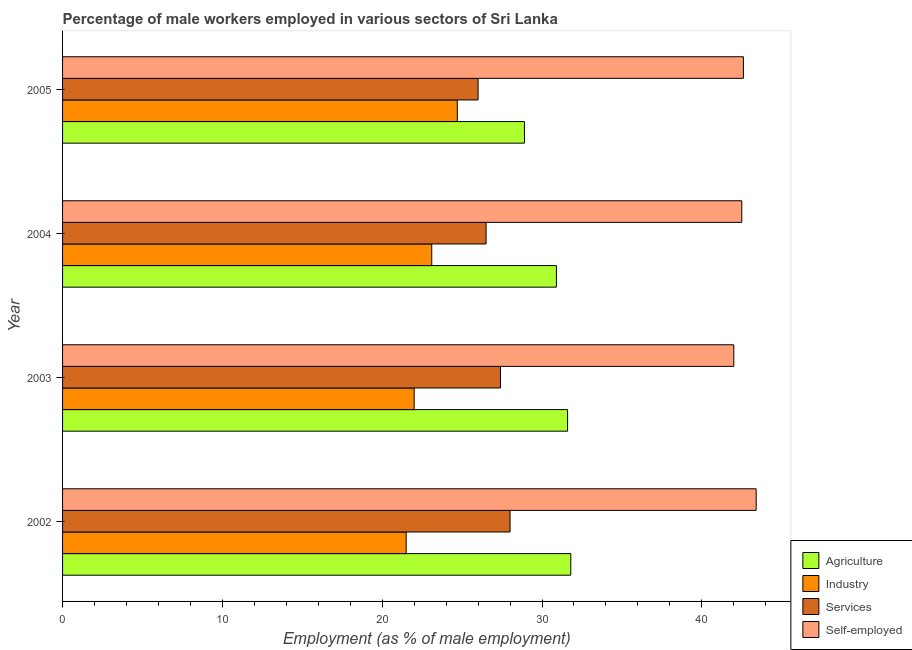In how many cases, is the number of bars for a given year not equal to the number of legend labels?
Offer a very short reply. 0. What is the percentage of male workers in agriculture in 2004?
Your answer should be very brief. 30.9. Across all years, what is the maximum percentage of male workers in industry?
Provide a short and direct response. 24.7. Across all years, what is the minimum percentage of male workers in industry?
Make the answer very short. 21.5. In which year was the percentage of male workers in agriculture maximum?
Provide a succinct answer. 2002. In which year was the percentage of male workers in industry minimum?
Give a very brief answer. 2002. What is the total percentage of male workers in services in the graph?
Ensure brevity in your answer.  107.9. What is the difference between the percentage of male workers in industry in 2005 and the percentage of male workers in agriculture in 2004?
Offer a very short reply. -6.2. What is the average percentage of male workers in agriculture per year?
Give a very brief answer. 30.8. In the year 2004, what is the difference between the percentage of male workers in agriculture and percentage of self employed male workers?
Give a very brief answer. -11.6. What is the ratio of the percentage of male workers in industry in 2002 to that in 2004?
Your answer should be very brief. 0.93. Is the percentage of male workers in agriculture in 2004 less than that in 2005?
Offer a very short reply. No. In how many years, is the percentage of self employed male workers greater than the average percentage of self employed male workers taken over all years?
Make the answer very short. 1. What does the 4th bar from the top in 2005 represents?
Offer a very short reply. Agriculture. What does the 4th bar from the bottom in 2005 represents?
Provide a short and direct response. Self-employed. How many bars are there?
Keep it short and to the point. 16. Are all the bars in the graph horizontal?
Give a very brief answer. Yes. Does the graph contain any zero values?
Ensure brevity in your answer.  No. Where does the legend appear in the graph?
Ensure brevity in your answer.  Bottom right. How many legend labels are there?
Your response must be concise. 4. How are the legend labels stacked?
Ensure brevity in your answer.  Vertical. What is the title of the graph?
Offer a terse response. Percentage of male workers employed in various sectors of Sri Lanka. Does "Public sector management" appear as one of the legend labels in the graph?
Offer a terse response. No. What is the label or title of the X-axis?
Your answer should be compact. Employment (as % of male employment). What is the label or title of the Y-axis?
Your answer should be very brief. Year. What is the Employment (as % of male employment) of Agriculture in 2002?
Your answer should be very brief. 31.8. What is the Employment (as % of male employment) in Industry in 2002?
Provide a succinct answer. 21.5. What is the Employment (as % of male employment) in Self-employed in 2002?
Ensure brevity in your answer.  43.4. What is the Employment (as % of male employment) in Agriculture in 2003?
Offer a very short reply. 31.6. What is the Employment (as % of male employment) of Services in 2003?
Offer a very short reply. 27.4. What is the Employment (as % of male employment) of Agriculture in 2004?
Ensure brevity in your answer.  30.9. What is the Employment (as % of male employment) in Industry in 2004?
Keep it short and to the point. 23.1. What is the Employment (as % of male employment) of Self-employed in 2004?
Your answer should be compact. 42.5. What is the Employment (as % of male employment) in Agriculture in 2005?
Your answer should be compact. 28.9. What is the Employment (as % of male employment) of Industry in 2005?
Your response must be concise. 24.7. What is the Employment (as % of male employment) of Services in 2005?
Provide a short and direct response. 26. What is the Employment (as % of male employment) of Self-employed in 2005?
Your answer should be compact. 42.6. Across all years, what is the maximum Employment (as % of male employment) of Agriculture?
Your response must be concise. 31.8. Across all years, what is the maximum Employment (as % of male employment) in Industry?
Make the answer very short. 24.7. Across all years, what is the maximum Employment (as % of male employment) in Self-employed?
Make the answer very short. 43.4. Across all years, what is the minimum Employment (as % of male employment) of Agriculture?
Make the answer very short. 28.9. What is the total Employment (as % of male employment) of Agriculture in the graph?
Offer a terse response. 123.2. What is the total Employment (as % of male employment) in Industry in the graph?
Offer a terse response. 91.3. What is the total Employment (as % of male employment) in Services in the graph?
Provide a short and direct response. 107.9. What is the total Employment (as % of male employment) in Self-employed in the graph?
Give a very brief answer. 170.5. What is the difference between the Employment (as % of male employment) in Agriculture in 2002 and that in 2003?
Give a very brief answer. 0.2. What is the difference between the Employment (as % of male employment) in Self-employed in 2002 and that in 2003?
Your answer should be very brief. 1.4. What is the difference between the Employment (as % of male employment) in Agriculture in 2002 and that in 2004?
Keep it short and to the point. 0.9. What is the difference between the Employment (as % of male employment) in Industry in 2002 and that in 2004?
Offer a terse response. -1.6. What is the difference between the Employment (as % of male employment) of Self-employed in 2002 and that in 2004?
Your response must be concise. 0.9. What is the difference between the Employment (as % of male employment) of Agriculture in 2002 and that in 2005?
Your answer should be very brief. 2.9. What is the difference between the Employment (as % of male employment) of Industry in 2002 and that in 2005?
Make the answer very short. -3.2. What is the difference between the Employment (as % of male employment) in Services in 2002 and that in 2005?
Offer a very short reply. 2. What is the difference between the Employment (as % of male employment) in Self-employed in 2002 and that in 2005?
Offer a very short reply. 0.8. What is the difference between the Employment (as % of male employment) of Services in 2003 and that in 2004?
Ensure brevity in your answer.  0.9. What is the difference between the Employment (as % of male employment) in Agriculture in 2003 and that in 2005?
Make the answer very short. 2.7. What is the difference between the Employment (as % of male employment) of Services in 2003 and that in 2005?
Provide a succinct answer. 1.4. What is the difference between the Employment (as % of male employment) of Self-employed in 2003 and that in 2005?
Your response must be concise. -0.6. What is the difference between the Employment (as % of male employment) in Agriculture in 2004 and that in 2005?
Provide a succinct answer. 2. What is the difference between the Employment (as % of male employment) of Industry in 2004 and that in 2005?
Ensure brevity in your answer.  -1.6. What is the difference between the Employment (as % of male employment) of Services in 2004 and that in 2005?
Ensure brevity in your answer.  0.5. What is the difference between the Employment (as % of male employment) of Agriculture in 2002 and the Employment (as % of male employment) of Industry in 2003?
Give a very brief answer. 9.8. What is the difference between the Employment (as % of male employment) of Industry in 2002 and the Employment (as % of male employment) of Self-employed in 2003?
Give a very brief answer. -20.5. What is the difference between the Employment (as % of male employment) of Agriculture in 2002 and the Employment (as % of male employment) of Industry in 2004?
Keep it short and to the point. 8.7. What is the difference between the Employment (as % of male employment) of Industry in 2002 and the Employment (as % of male employment) of Services in 2004?
Your answer should be compact. -5. What is the difference between the Employment (as % of male employment) of Industry in 2002 and the Employment (as % of male employment) of Self-employed in 2004?
Offer a terse response. -21. What is the difference between the Employment (as % of male employment) of Services in 2002 and the Employment (as % of male employment) of Self-employed in 2004?
Your answer should be compact. -14.5. What is the difference between the Employment (as % of male employment) of Agriculture in 2002 and the Employment (as % of male employment) of Industry in 2005?
Provide a short and direct response. 7.1. What is the difference between the Employment (as % of male employment) of Agriculture in 2002 and the Employment (as % of male employment) of Services in 2005?
Ensure brevity in your answer.  5.8. What is the difference between the Employment (as % of male employment) in Industry in 2002 and the Employment (as % of male employment) in Services in 2005?
Your response must be concise. -4.5. What is the difference between the Employment (as % of male employment) of Industry in 2002 and the Employment (as % of male employment) of Self-employed in 2005?
Keep it short and to the point. -21.1. What is the difference between the Employment (as % of male employment) in Services in 2002 and the Employment (as % of male employment) in Self-employed in 2005?
Offer a terse response. -14.6. What is the difference between the Employment (as % of male employment) of Agriculture in 2003 and the Employment (as % of male employment) of Industry in 2004?
Offer a terse response. 8.5. What is the difference between the Employment (as % of male employment) of Agriculture in 2003 and the Employment (as % of male employment) of Services in 2004?
Provide a succinct answer. 5.1. What is the difference between the Employment (as % of male employment) of Agriculture in 2003 and the Employment (as % of male employment) of Self-employed in 2004?
Your answer should be compact. -10.9. What is the difference between the Employment (as % of male employment) in Industry in 2003 and the Employment (as % of male employment) in Services in 2004?
Offer a terse response. -4.5. What is the difference between the Employment (as % of male employment) of Industry in 2003 and the Employment (as % of male employment) of Self-employed in 2004?
Offer a very short reply. -20.5. What is the difference between the Employment (as % of male employment) in Services in 2003 and the Employment (as % of male employment) in Self-employed in 2004?
Ensure brevity in your answer.  -15.1. What is the difference between the Employment (as % of male employment) in Industry in 2003 and the Employment (as % of male employment) in Services in 2005?
Your response must be concise. -4. What is the difference between the Employment (as % of male employment) of Industry in 2003 and the Employment (as % of male employment) of Self-employed in 2005?
Your answer should be compact. -20.6. What is the difference between the Employment (as % of male employment) of Services in 2003 and the Employment (as % of male employment) of Self-employed in 2005?
Your answer should be compact. -15.2. What is the difference between the Employment (as % of male employment) of Agriculture in 2004 and the Employment (as % of male employment) of Services in 2005?
Your response must be concise. 4.9. What is the difference between the Employment (as % of male employment) of Industry in 2004 and the Employment (as % of male employment) of Self-employed in 2005?
Ensure brevity in your answer.  -19.5. What is the difference between the Employment (as % of male employment) in Services in 2004 and the Employment (as % of male employment) in Self-employed in 2005?
Your answer should be compact. -16.1. What is the average Employment (as % of male employment) of Agriculture per year?
Make the answer very short. 30.8. What is the average Employment (as % of male employment) in Industry per year?
Ensure brevity in your answer.  22.82. What is the average Employment (as % of male employment) in Services per year?
Keep it short and to the point. 26.98. What is the average Employment (as % of male employment) of Self-employed per year?
Offer a very short reply. 42.62. In the year 2002, what is the difference between the Employment (as % of male employment) in Agriculture and Employment (as % of male employment) in Industry?
Make the answer very short. 10.3. In the year 2002, what is the difference between the Employment (as % of male employment) of Industry and Employment (as % of male employment) of Services?
Keep it short and to the point. -6.5. In the year 2002, what is the difference between the Employment (as % of male employment) of Industry and Employment (as % of male employment) of Self-employed?
Provide a short and direct response. -21.9. In the year 2002, what is the difference between the Employment (as % of male employment) in Services and Employment (as % of male employment) in Self-employed?
Your answer should be very brief. -15.4. In the year 2003, what is the difference between the Employment (as % of male employment) in Agriculture and Employment (as % of male employment) in Industry?
Keep it short and to the point. 9.6. In the year 2003, what is the difference between the Employment (as % of male employment) of Agriculture and Employment (as % of male employment) of Services?
Offer a very short reply. 4.2. In the year 2003, what is the difference between the Employment (as % of male employment) in Industry and Employment (as % of male employment) in Services?
Provide a short and direct response. -5.4. In the year 2003, what is the difference between the Employment (as % of male employment) of Services and Employment (as % of male employment) of Self-employed?
Offer a very short reply. -14.6. In the year 2004, what is the difference between the Employment (as % of male employment) in Agriculture and Employment (as % of male employment) in Services?
Make the answer very short. 4.4. In the year 2004, what is the difference between the Employment (as % of male employment) of Industry and Employment (as % of male employment) of Services?
Provide a short and direct response. -3.4. In the year 2004, what is the difference between the Employment (as % of male employment) of Industry and Employment (as % of male employment) of Self-employed?
Keep it short and to the point. -19.4. In the year 2004, what is the difference between the Employment (as % of male employment) of Services and Employment (as % of male employment) of Self-employed?
Your answer should be very brief. -16. In the year 2005, what is the difference between the Employment (as % of male employment) of Agriculture and Employment (as % of male employment) of Industry?
Ensure brevity in your answer.  4.2. In the year 2005, what is the difference between the Employment (as % of male employment) of Agriculture and Employment (as % of male employment) of Self-employed?
Offer a terse response. -13.7. In the year 2005, what is the difference between the Employment (as % of male employment) of Industry and Employment (as % of male employment) of Self-employed?
Offer a terse response. -17.9. In the year 2005, what is the difference between the Employment (as % of male employment) in Services and Employment (as % of male employment) in Self-employed?
Ensure brevity in your answer.  -16.6. What is the ratio of the Employment (as % of male employment) in Agriculture in 2002 to that in 2003?
Offer a very short reply. 1.01. What is the ratio of the Employment (as % of male employment) in Industry in 2002 to that in 2003?
Give a very brief answer. 0.98. What is the ratio of the Employment (as % of male employment) of Services in 2002 to that in 2003?
Provide a short and direct response. 1.02. What is the ratio of the Employment (as % of male employment) in Agriculture in 2002 to that in 2004?
Provide a succinct answer. 1.03. What is the ratio of the Employment (as % of male employment) of Industry in 2002 to that in 2004?
Your answer should be very brief. 0.93. What is the ratio of the Employment (as % of male employment) in Services in 2002 to that in 2004?
Your answer should be compact. 1.06. What is the ratio of the Employment (as % of male employment) in Self-employed in 2002 to that in 2004?
Provide a short and direct response. 1.02. What is the ratio of the Employment (as % of male employment) of Agriculture in 2002 to that in 2005?
Offer a very short reply. 1.1. What is the ratio of the Employment (as % of male employment) in Industry in 2002 to that in 2005?
Offer a terse response. 0.87. What is the ratio of the Employment (as % of male employment) in Self-employed in 2002 to that in 2005?
Offer a terse response. 1.02. What is the ratio of the Employment (as % of male employment) of Agriculture in 2003 to that in 2004?
Keep it short and to the point. 1.02. What is the ratio of the Employment (as % of male employment) in Services in 2003 to that in 2004?
Your response must be concise. 1.03. What is the ratio of the Employment (as % of male employment) in Agriculture in 2003 to that in 2005?
Offer a very short reply. 1.09. What is the ratio of the Employment (as % of male employment) in Industry in 2003 to that in 2005?
Ensure brevity in your answer.  0.89. What is the ratio of the Employment (as % of male employment) in Services in 2003 to that in 2005?
Offer a very short reply. 1.05. What is the ratio of the Employment (as % of male employment) of Self-employed in 2003 to that in 2005?
Give a very brief answer. 0.99. What is the ratio of the Employment (as % of male employment) of Agriculture in 2004 to that in 2005?
Your answer should be compact. 1.07. What is the ratio of the Employment (as % of male employment) of Industry in 2004 to that in 2005?
Ensure brevity in your answer.  0.94. What is the ratio of the Employment (as % of male employment) in Services in 2004 to that in 2005?
Provide a succinct answer. 1.02. What is the ratio of the Employment (as % of male employment) in Self-employed in 2004 to that in 2005?
Keep it short and to the point. 1. What is the difference between the highest and the second highest Employment (as % of male employment) of Industry?
Provide a short and direct response. 1.6. What is the difference between the highest and the second highest Employment (as % of male employment) in Self-employed?
Offer a terse response. 0.8. What is the difference between the highest and the lowest Employment (as % of male employment) in Agriculture?
Provide a succinct answer. 2.9. What is the difference between the highest and the lowest Employment (as % of male employment) in Services?
Your response must be concise. 2. 